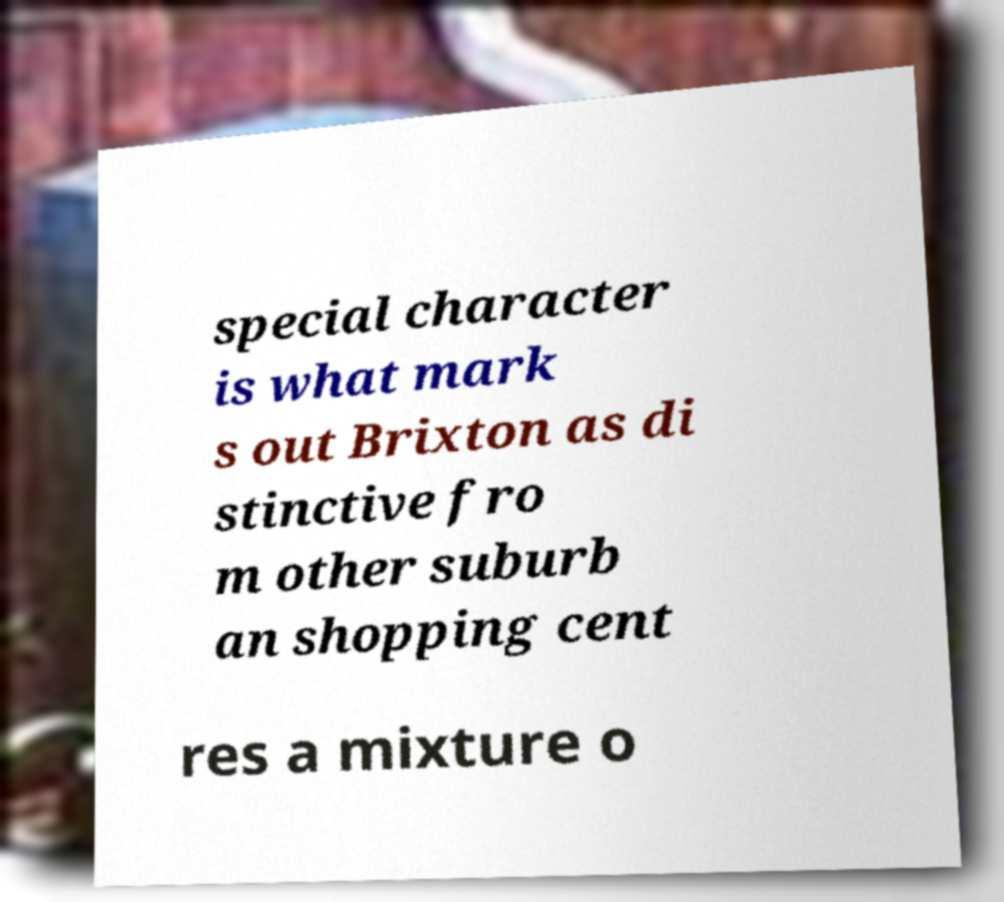What messages or text are displayed in this image? I need them in a readable, typed format. special character is what mark s out Brixton as di stinctive fro m other suburb an shopping cent res a mixture o 